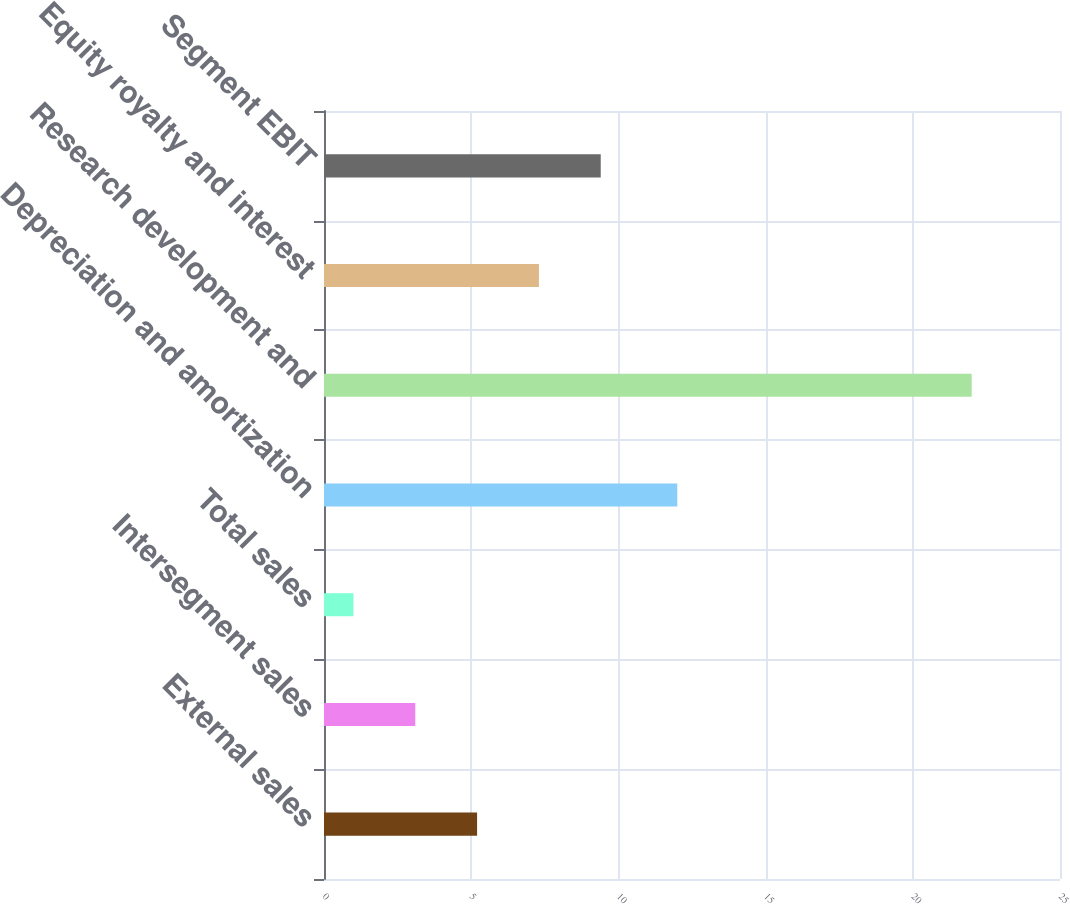Convert chart to OTSL. <chart><loc_0><loc_0><loc_500><loc_500><bar_chart><fcel>External sales<fcel>Intersegment sales<fcel>Total sales<fcel>Depreciation and amortization<fcel>Research development and<fcel>Equity royalty and interest<fcel>Segment EBIT<nl><fcel>5.2<fcel>3.1<fcel>1<fcel>12<fcel>22<fcel>7.3<fcel>9.4<nl></chart> 